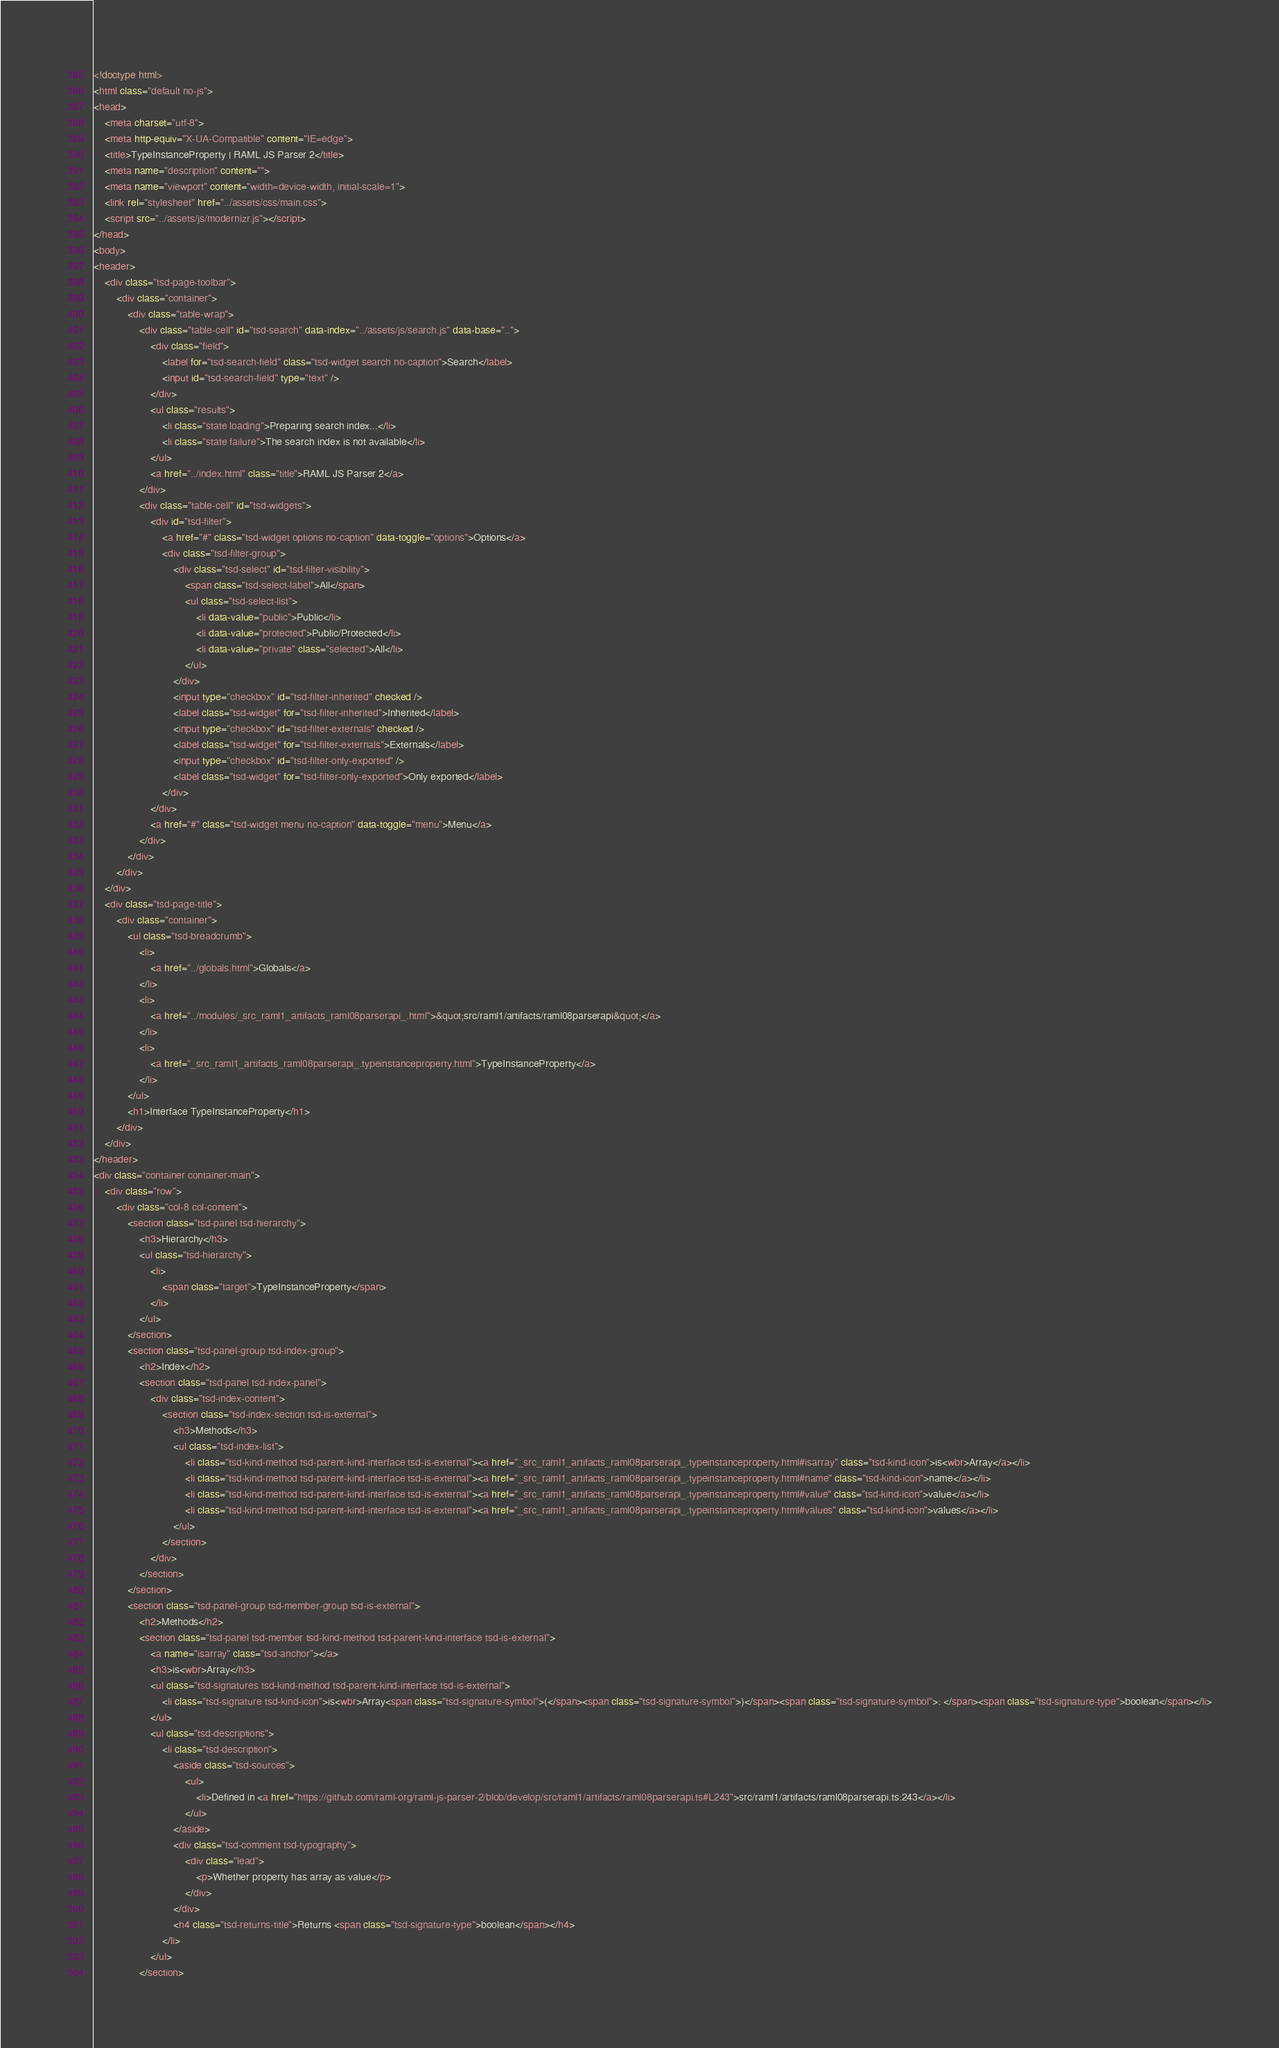<code> <loc_0><loc_0><loc_500><loc_500><_HTML_><!doctype html>
<html class="default no-js">
<head>
	<meta charset="utf-8">
	<meta http-equiv="X-UA-Compatible" content="IE=edge">
	<title>TypeInstanceProperty | RAML JS Parser 2</title>
	<meta name="description" content="">
	<meta name="viewport" content="width=device-width, initial-scale=1">
	<link rel="stylesheet" href="../assets/css/main.css">
	<script src="../assets/js/modernizr.js"></script>
</head>
<body>
<header>
	<div class="tsd-page-toolbar">
		<div class="container">
			<div class="table-wrap">
				<div class="table-cell" id="tsd-search" data-index="../assets/js/search.js" data-base="..">
					<div class="field">
						<label for="tsd-search-field" class="tsd-widget search no-caption">Search</label>
						<input id="tsd-search-field" type="text" />
					</div>
					<ul class="results">
						<li class="state loading">Preparing search index...</li>
						<li class="state failure">The search index is not available</li>
					</ul>
					<a href="../index.html" class="title">RAML JS Parser 2</a>
				</div>
				<div class="table-cell" id="tsd-widgets">
					<div id="tsd-filter">
						<a href="#" class="tsd-widget options no-caption" data-toggle="options">Options</a>
						<div class="tsd-filter-group">
							<div class="tsd-select" id="tsd-filter-visibility">
								<span class="tsd-select-label">All</span>
								<ul class="tsd-select-list">
									<li data-value="public">Public</li>
									<li data-value="protected">Public/Protected</li>
									<li data-value="private" class="selected">All</li>
								</ul>
							</div>
							<input type="checkbox" id="tsd-filter-inherited" checked />
							<label class="tsd-widget" for="tsd-filter-inherited">Inherited</label>
							<input type="checkbox" id="tsd-filter-externals" checked />
							<label class="tsd-widget" for="tsd-filter-externals">Externals</label>
							<input type="checkbox" id="tsd-filter-only-exported" />
							<label class="tsd-widget" for="tsd-filter-only-exported">Only exported</label>
						</div>
					</div>
					<a href="#" class="tsd-widget menu no-caption" data-toggle="menu">Menu</a>
				</div>
			</div>
		</div>
	</div>
	<div class="tsd-page-title">
		<div class="container">
			<ul class="tsd-breadcrumb">
				<li>
					<a href="../globals.html">Globals</a>
				</li>
				<li>
					<a href="../modules/_src_raml1_artifacts_raml08parserapi_.html">&quot;src/raml1/artifacts/raml08parserapi&quot;</a>
				</li>
				<li>
					<a href="_src_raml1_artifacts_raml08parserapi_.typeinstanceproperty.html">TypeInstanceProperty</a>
				</li>
			</ul>
			<h1>Interface TypeInstanceProperty</h1>
		</div>
	</div>
</header>
<div class="container container-main">
	<div class="row">
		<div class="col-8 col-content">
			<section class="tsd-panel tsd-hierarchy">
				<h3>Hierarchy</h3>
				<ul class="tsd-hierarchy">
					<li>
						<span class="target">TypeInstanceProperty</span>
					</li>
				</ul>
			</section>
			<section class="tsd-panel-group tsd-index-group">
				<h2>Index</h2>
				<section class="tsd-panel tsd-index-panel">
					<div class="tsd-index-content">
						<section class="tsd-index-section tsd-is-external">
							<h3>Methods</h3>
							<ul class="tsd-index-list">
								<li class="tsd-kind-method tsd-parent-kind-interface tsd-is-external"><a href="_src_raml1_artifacts_raml08parserapi_.typeinstanceproperty.html#isarray" class="tsd-kind-icon">is<wbr>Array</a></li>
								<li class="tsd-kind-method tsd-parent-kind-interface tsd-is-external"><a href="_src_raml1_artifacts_raml08parserapi_.typeinstanceproperty.html#name" class="tsd-kind-icon">name</a></li>
								<li class="tsd-kind-method tsd-parent-kind-interface tsd-is-external"><a href="_src_raml1_artifacts_raml08parserapi_.typeinstanceproperty.html#value" class="tsd-kind-icon">value</a></li>
								<li class="tsd-kind-method tsd-parent-kind-interface tsd-is-external"><a href="_src_raml1_artifacts_raml08parserapi_.typeinstanceproperty.html#values" class="tsd-kind-icon">values</a></li>
							</ul>
						</section>
					</div>
				</section>
			</section>
			<section class="tsd-panel-group tsd-member-group tsd-is-external">
				<h2>Methods</h2>
				<section class="tsd-panel tsd-member tsd-kind-method tsd-parent-kind-interface tsd-is-external">
					<a name="isarray" class="tsd-anchor"></a>
					<h3>is<wbr>Array</h3>
					<ul class="tsd-signatures tsd-kind-method tsd-parent-kind-interface tsd-is-external">
						<li class="tsd-signature tsd-kind-icon">is<wbr>Array<span class="tsd-signature-symbol">(</span><span class="tsd-signature-symbol">)</span><span class="tsd-signature-symbol">: </span><span class="tsd-signature-type">boolean</span></li>
					</ul>
					<ul class="tsd-descriptions">
						<li class="tsd-description">
							<aside class="tsd-sources">
								<ul>
									<li>Defined in <a href="https://github.com/raml-org/raml-js-parser-2/blob/develop/src/raml1/artifacts/raml08parserapi.ts#L243">src/raml1/artifacts/raml08parserapi.ts:243</a></li>
								</ul>
							</aside>
							<div class="tsd-comment tsd-typography">
								<div class="lead">
									<p>Whether property has array as value</p>
								</div>
							</div>
							<h4 class="tsd-returns-title">Returns <span class="tsd-signature-type">boolean</span></h4>
						</li>
					</ul>
				</section></code> 